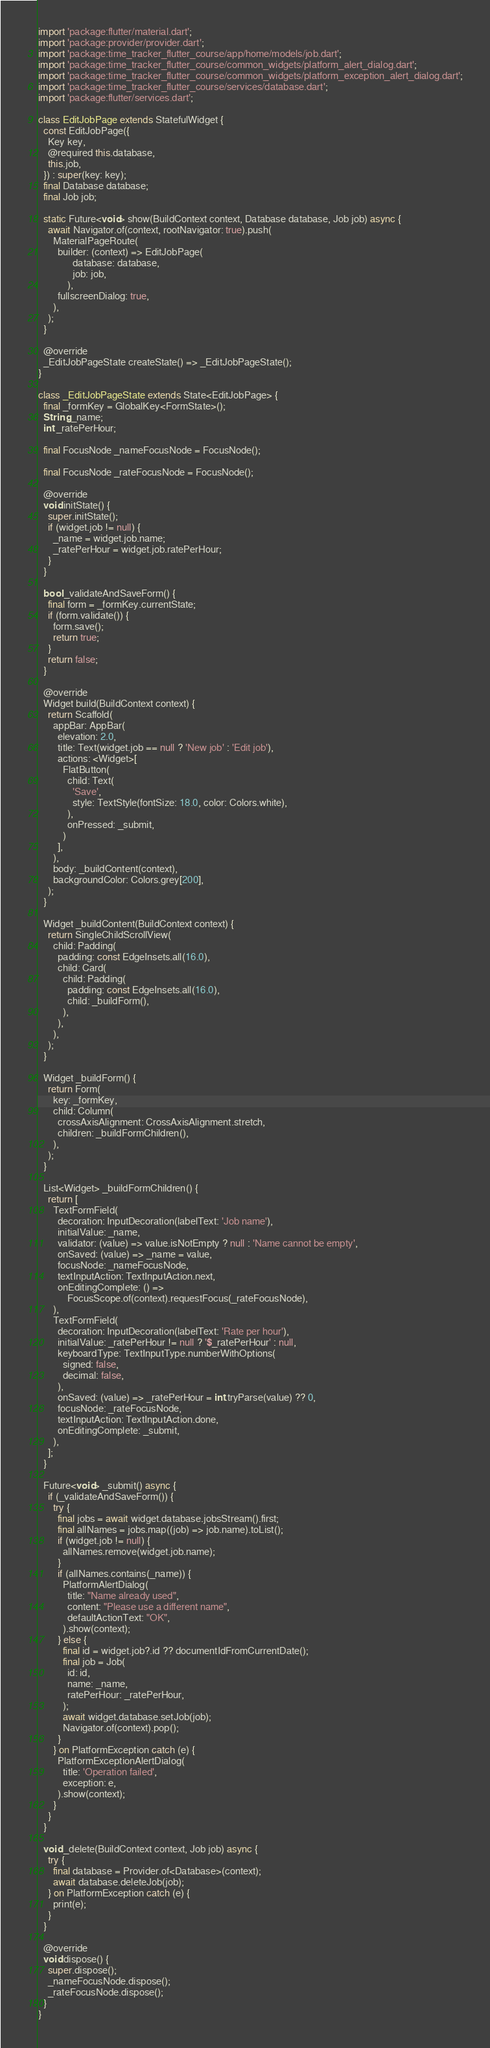Convert code to text. <code><loc_0><loc_0><loc_500><loc_500><_Dart_>import 'package:flutter/material.dart';
import 'package:provider/provider.dart';
import 'package:time_tracker_flutter_course/app/home/models/job.dart';
import 'package:time_tracker_flutter_course/common_widgets/platform_alert_dialog.dart';
import 'package:time_tracker_flutter_course/common_widgets/platform_exception_alert_dialog.dart';
import 'package:time_tracker_flutter_course/services/database.dart';
import 'package:flutter/services.dart';

class EditJobPage extends StatefulWidget {
  const EditJobPage({
    Key key,
    @required this.database,
    this.job,
  }) : super(key: key);
  final Database database;
  final Job job;

  static Future<void> show(BuildContext context, Database database, Job job) async {
    await Navigator.of(context, rootNavigator: true).push(
      MaterialPageRoute(
        builder: (context) => EditJobPage(
              database: database,
              job: job,
            ),
        fullscreenDialog: true,
      ),
    );
  }

  @override
  _EditJobPageState createState() => _EditJobPageState();
}

class _EditJobPageState extends State<EditJobPage> {
  final _formKey = GlobalKey<FormState>();
  String _name;
  int _ratePerHour;

  final FocusNode _nameFocusNode = FocusNode();

  final FocusNode _rateFocusNode = FocusNode();

  @override
  void initState() {
    super.initState();
    if (widget.job != null) {
      _name = widget.job.name;
      _ratePerHour = widget.job.ratePerHour;
    }
  }

  bool _validateAndSaveForm() {
    final form = _formKey.currentState;
    if (form.validate()) {
      form.save();
      return true;
    }
    return false;
  }

  @override
  Widget build(BuildContext context) {
    return Scaffold(
      appBar: AppBar(
        elevation: 2.0,
        title: Text(widget.job == null ? 'New job' : 'Edit job'),
        actions: <Widget>[
          FlatButton(
            child: Text(
              'Save',
              style: TextStyle(fontSize: 18.0, color: Colors.white),
            ),
            onPressed: _submit,
          )
        ],
      ),
      body: _buildContent(context),
      backgroundColor: Colors.grey[200],
    );
  }

  Widget _buildContent(BuildContext context) {
    return SingleChildScrollView(
      child: Padding(
        padding: const EdgeInsets.all(16.0),
        child: Card(
          child: Padding(
            padding: const EdgeInsets.all(16.0),
            child: _buildForm(),
          ),
        ),
      ),
    );
  }

  Widget _buildForm() {
    return Form(
      key: _formKey,
      child: Column(
        crossAxisAlignment: CrossAxisAlignment.stretch,
        children: _buildFormChildren(),
      ),
    );
  }

  List<Widget> _buildFormChildren() {
    return [
      TextFormField(
        decoration: InputDecoration(labelText: 'Job name'),
        initialValue: _name,
        validator: (value) => value.isNotEmpty ? null : 'Name cannot be empty',
        onSaved: (value) => _name = value,
        focusNode: _nameFocusNode,
        textInputAction: TextInputAction.next,
        onEditingComplete: () =>
            FocusScope.of(context).requestFocus(_rateFocusNode),
      ),
      TextFormField(
        decoration: InputDecoration(labelText: 'Rate per hour'),
        initialValue: _ratePerHour != null ? '$_ratePerHour' : null,
        keyboardType: TextInputType.numberWithOptions(
          signed: false,
          decimal: false,
        ),
        onSaved: (value) => _ratePerHour = int.tryParse(value) ?? 0,
        focusNode: _rateFocusNode,
        textInputAction: TextInputAction.done,
        onEditingComplete: _submit,
      ),
    ];
  }

  Future<void> _submit() async {
    if (_validateAndSaveForm()) {
      try {
        final jobs = await widget.database.jobsStream().first;
        final allNames = jobs.map((job) => job.name).toList();
        if (widget.job != null) {
          allNames.remove(widget.job.name);
        }
        if (allNames.contains(_name)) {
          PlatformAlertDialog(
            title: "Name already used",
            content: "Please use a different name",
            defaultActionText: "OK",
          ).show(context);
        } else {
          final id = widget.job?.id ?? documentIdFromCurrentDate();
          final job = Job(
            id: id,
            name: _name,
            ratePerHour: _ratePerHour,
          );
          await widget.database.setJob(job);
          Navigator.of(context).pop();
        }
      } on PlatformException catch (e) {
        PlatformExceptionAlertDialog(
          title: 'Operation failed',
          exception: e,
        ).show(context);
      }
    }
  }

  void _delete(BuildContext context, Job job) async {
    try {
      final database = Provider.of<Database>(context);
      await database.deleteJob(job);
    } on PlatformException catch (e) {
      print(e);
    }
  }

  @override
  void dispose() {
    super.dispose();
    _nameFocusNode.dispose();
    _rateFocusNode.dispose();
  }
}
</code> 